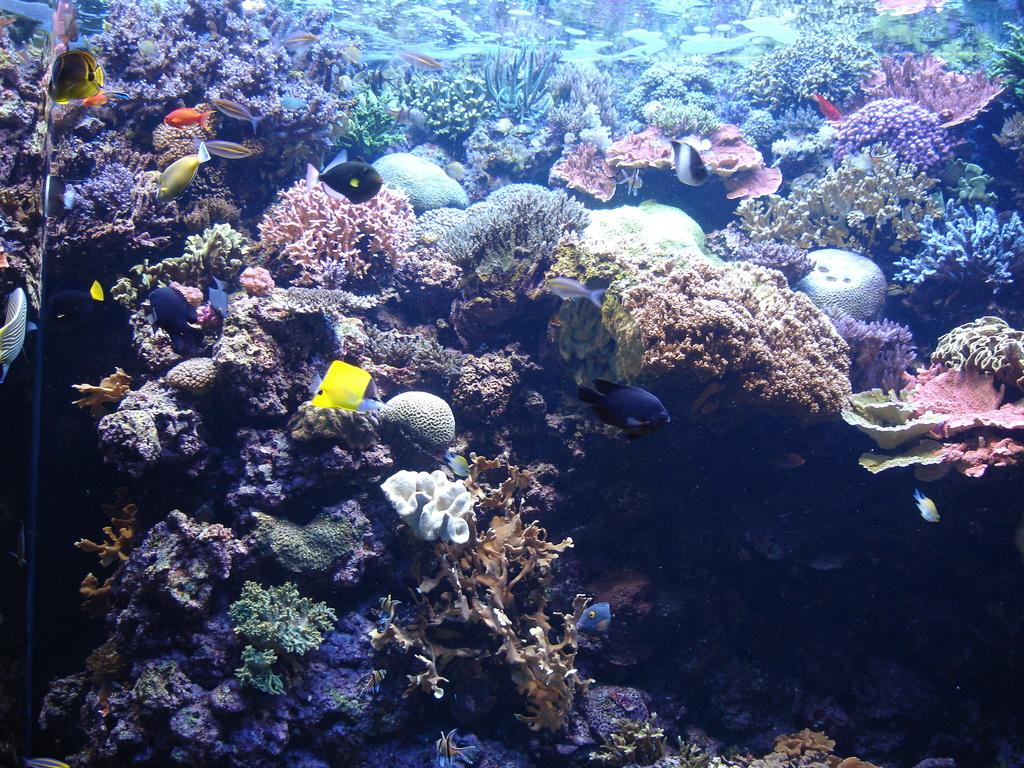What type of plant life is visible in the image? The image contains coral leaves. What other living organisms can be seen in the image? The image contains fishes. Can you describe the environment in which the image was taken? The image appears to be taken underwater. What type of muscle can be seen flexing in the image? There is no muscle visible in the image, as it features underwater coral leaves and fishes. --- Facts: 1. There is a person sitting on a chair in the image. 2. The person is holding a book. 3. The book has a blue cover. 4. There is a table next to the chair. 5. The table has a lamp on it. Absurd Topics: elephant, ocean, bicycle Conversation: What is the person in the image doing? The person is sitting on a chair in the image. What object is the person holding? The person is holding a book. Can you describe the book's appearance? The book has a blue cover. What is located next to the chair in the image? There is a table next to the chair. What object is on the table? The table has a lamp on it. Reasoning: Let's think step by step in order to produce the conversation. We start by identifying the main subject in the image, which is the person sitting on a chair. Then, we expand the conversation to include other items that are also visible, such as the book, the table, and the lamp. Each question is designed to elicit a specific detail about the image that is known from the provided facts. Absurd Question/Answer: Can you see an elephant swimming in the ocean in the image? No, there is no elephant or ocean present in the image; it features a person sitting on a chair holding a book. 